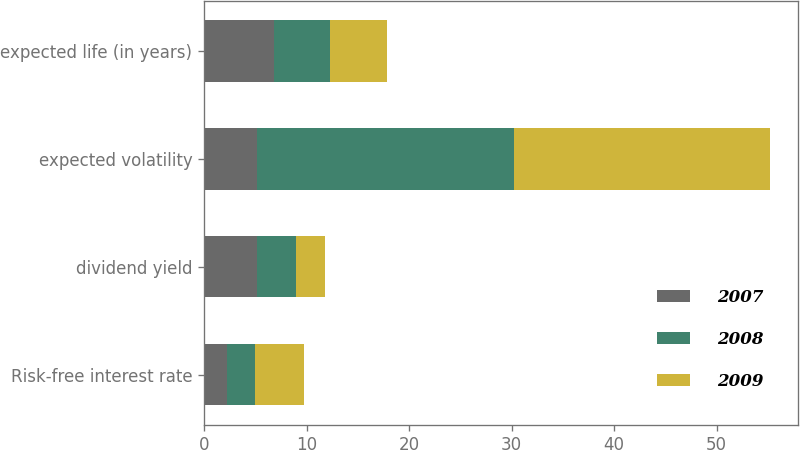Convert chart. <chart><loc_0><loc_0><loc_500><loc_500><stacked_bar_chart><ecel><fcel>Risk-free interest rate<fcel>dividend yield<fcel>expected volatility<fcel>expected life (in years)<nl><fcel>2007<fcel>2.2<fcel>5.2<fcel>5.2<fcel>6.8<nl><fcel>2008<fcel>2.8<fcel>3.8<fcel>25<fcel>5.5<nl><fcel>2009<fcel>4.7<fcel>2.8<fcel>25<fcel>5.5<nl></chart> 